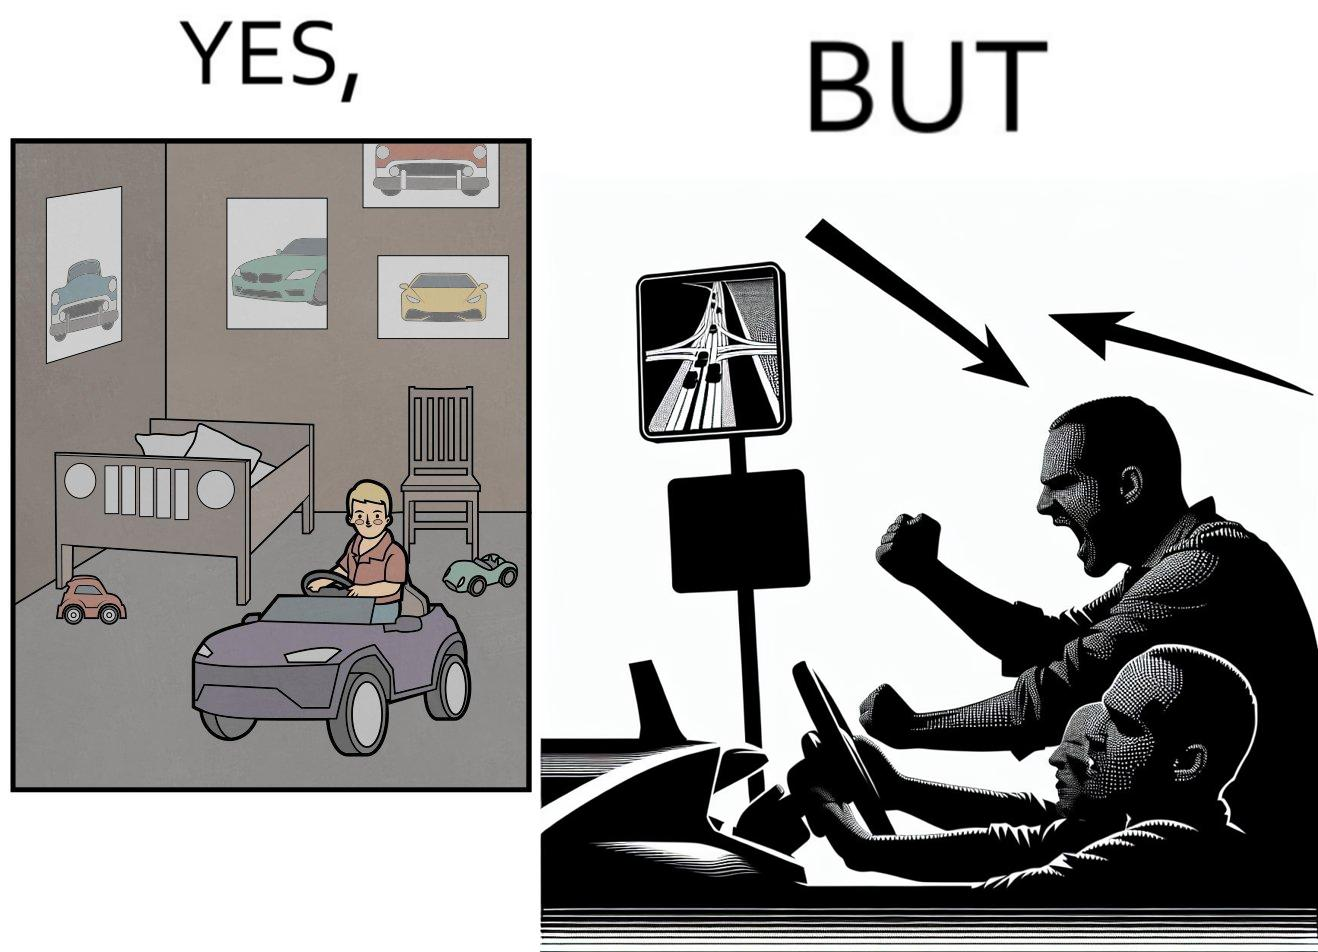Describe what you see in the left and right parts of this image. In the left part of the image: The image shows the bedroom of a child with various small toy cars and posters of cars on the wall. The child in the picture is also riding a bigger toy car. In the right part of the image: The image shows a man annoyed by the slow traffic on his way as shown on the map while he is driving. 